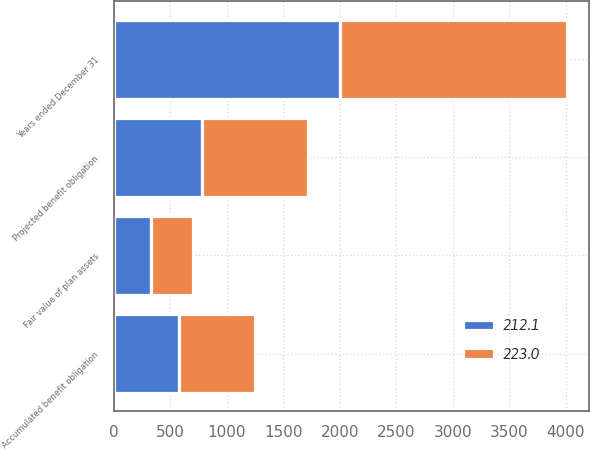Convert chart. <chart><loc_0><loc_0><loc_500><loc_500><stacked_bar_chart><ecel><fcel>Years ended December 31<fcel>Projected benefit obligation<fcel>Fair value of plan assets<fcel>Accumulated benefit obligation<nl><fcel>223<fcel>2004<fcel>941.9<fcel>378.5<fcel>675.4<nl><fcel>212.1<fcel>2003<fcel>778.6<fcel>324.2<fcel>574.4<nl></chart> 